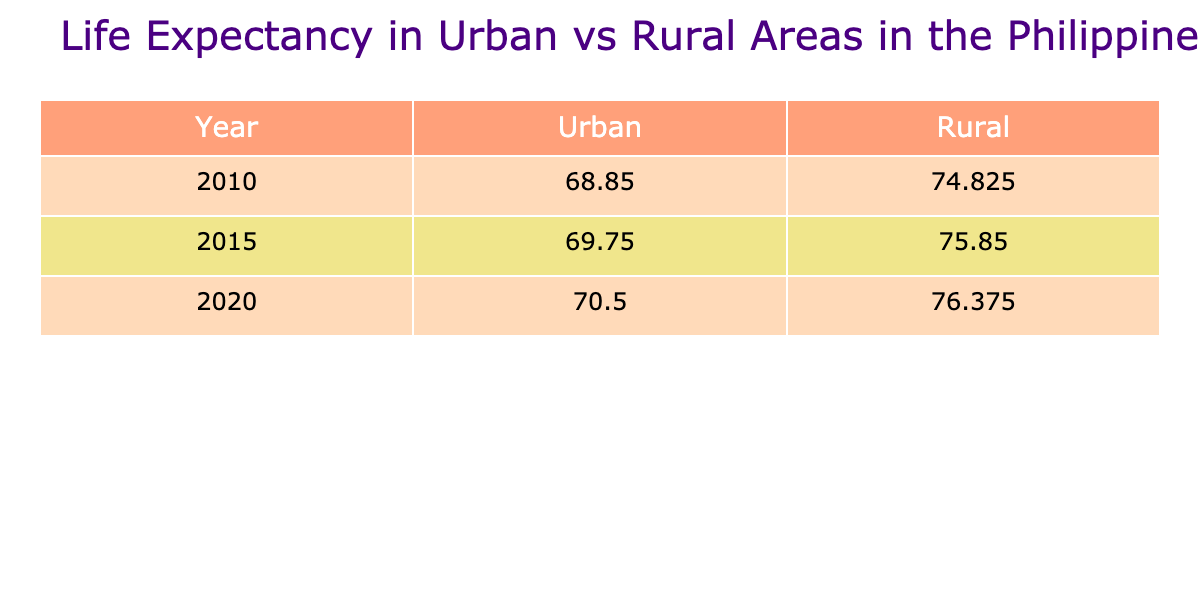What was the life expectancy in Manila in 2015? According to the table, the life expectancy in Manila in 2015 is listed as 75.4 years.
Answer: 75.4 What is the average life expectancy in rural areas for the year 2020? The life expectancies in rural areas for 2020 are: Bukidnon (71.0), Samar (69.0), Ifugao (70.0), and Negros Occidental (72.0). Adding these values gives 71.0 + 69.0 + 70.0 + 72.0 = 282. There are 4 data points, so the average is 282 / 4 = 70.5.
Answer: 70.5 Is the life expectancy in Cebu City higher than in Davao City for the year 2010? Looking at the table for 2010, Cebu City's life expectancy is 75.2 years, while Davao City's is 73.5 years. Therefore, Cebu City has a higher life expectancy than Davao City.
Answer: Yes What year recorded the highest life expectancy for urban areas? In the table, the urban life expectancies for the years are: 2010 (74.6), 2015 (75.4), and 2020 (76.0). The highest value is from 2020. Thus, the highest life expectancy recorded for urban areas is 76.0 years in 2020.
Answer: 76.0 years in 2020 What is the difference in life expectancy between the rural area with the highest life expectancy and the lowest life expectancy in 2015? In 2015, the rural area with the highest life expectancy is Bukidnon at 70.5 years, while the lowest is Samar at 68.0 years. The difference is 70.5 - 68.0 = 2.5 years.
Answer: 2.5 years What trend can be observed in urban life expectancy from 2010 to 2020? From the table, the urban life expectancy data shows an increase: 74.6 (2010), 75.4 (2015), and 76.0 (2020). Each of these years shows a consistent increase in life expectancy indicating a positive trend over this decade.
Answer: Increased trend Was the life expectancy of rural areas higher than urban areas in 2010? Referring to the table for 2010, the average life expectancy for urban areas is (74.6 + 73.5 + 75.2 + 76.0) / 4 = 74.825, while for rural areas it is (69.8 + 67.5 + 68.0 + 70.1) / 4 = 68.35. Since 74.825 is greater than 68.35, urban life expectancy was higher.
Answer: No Which urban area experienced the largest increase in life expectancy from 2010 to 2020? Looking at the urban areas, the life expectancies from 2010 to 2020 are as follows: Manila (74.6 to 76.0 = +1.4), Davao City (73.5 to 74.5 = +1.0), Cebu City (75.2 to 77.0 = +1.8), and Quezon City (76.0 to 78.0 = +2.0). The largest increase occurred in Quezon City, with an increase of 2.0 years.
Answer: Quezon City What is the overall trend in life expectancy for rural areas from 2010 to 2020? The life expectancies for rural areas across the years are: 2010 (69.8, 67.5, 68.0, 70.1), 2015 (70.5, 68.0, 69.5, 71.0), and 2020 (71.0, 69.0, 70.0, 72.0). Calculating the averages: 2010 = 68.4, 2015 = 69.8, 2020 = 70.5 shows a gradual increase in life expectancy over these years. Thus, rural areas show a positive trend in life expectancy.
Answer: Positive trend 